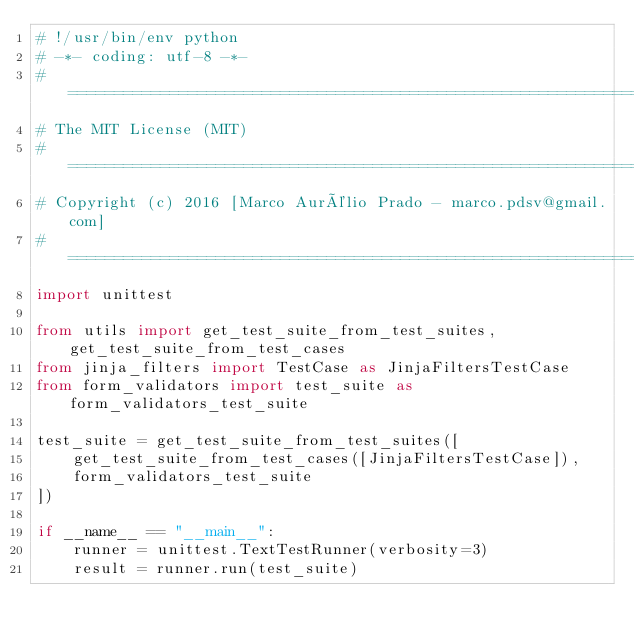<code> <loc_0><loc_0><loc_500><loc_500><_Python_># !/usr/bin/env python
# -*- coding: utf-8 -*-
# ======================================================================================================================
# The MIT License (MIT)
# ======================================================================================================================
# Copyright (c) 2016 [Marco Aurélio Prado - marco.pdsv@gmail.com]
# ======================================================================================================================
import unittest

from utils import get_test_suite_from_test_suites, get_test_suite_from_test_cases
from jinja_filters import TestCase as JinjaFiltersTestCase
from form_validators import test_suite as form_validators_test_suite

test_suite = get_test_suite_from_test_suites([
    get_test_suite_from_test_cases([JinjaFiltersTestCase]),
    form_validators_test_suite
])

if __name__ == "__main__":
    runner = unittest.TextTestRunner(verbosity=3)
    result = runner.run(test_suite)
</code> 